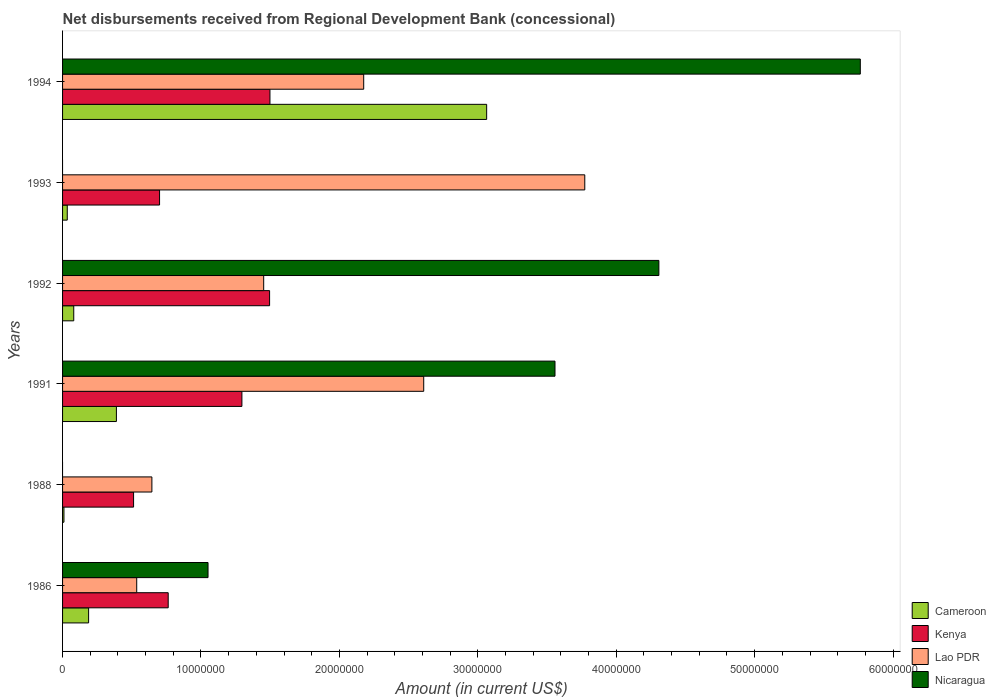How many different coloured bars are there?
Offer a terse response. 4. How many groups of bars are there?
Keep it short and to the point. 6. In how many cases, is the number of bars for a given year not equal to the number of legend labels?
Your response must be concise. 2. What is the amount of disbursements received from Regional Development Bank in Nicaragua in 1986?
Offer a very short reply. 1.05e+07. Across all years, what is the maximum amount of disbursements received from Regional Development Bank in Kenya?
Your response must be concise. 1.50e+07. What is the total amount of disbursements received from Regional Development Bank in Kenya in the graph?
Your answer should be compact. 6.27e+07. What is the difference between the amount of disbursements received from Regional Development Bank in Lao PDR in 1988 and that in 1991?
Your answer should be compact. -1.96e+07. What is the difference between the amount of disbursements received from Regional Development Bank in Cameroon in 1988 and the amount of disbursements received from Regional Development Bank in Kenya in 1986?
Ensure brevity in your answer.  -7.53e+06. What is the average amount of disbursements received from Regional Development Bank in Nicaragua per year?
Your answer should be compact. 2.45e+07. In the year 1986, what is the difference between the amount of disbursements received from Regional Development Bank in Cameroon and amount of disbursements received from Regional Development Bank in Nicaragua?
Your response must be concise. -8.63e+06. What is the ratio of the amount of disbursements received from Regional Development Bank in Nicaragua in 1986 to that in 1992?
Provide a short and direct response. 0.24. What is the difference between the highest and the second highest amount of disbursements received from Regional Development Bank in Nicaragua?
Give a very brief answer. 1.46e+07. What is the difference between the highest and the lowest amount of disbursements received from Regional Development Bank in Lao PDR?
Your answer should be very brief. 3.24e+07. In how many years, is the amount of disbursements received from Regional Development Bank in Lao PDR greater than the average amount of disbursements received from Regional Development Bank in Lao PDR taken over all years?
Your answer should be compact. 3. Is the sum of the amount of disbursements received from Regional Development Bank in Kenya in 1986 and 1988 greater than the maximum amount of disbursements received from Regional Development Bank in Nicaragua across all years?
Provide a short and direct response. No. Is it the case that in every year, the sum of the amount of disbursements received from Regional Development Bank in Kenya and amount of disbursements received from Regional Development Bank in Lao PDR is greater than the amount of disbursements received from Regional Development Bank in Cameroon?
Your response must be concise. Yes. Are all the bars in the graph horizontal?
Provide a succinct answer. Yes. What is the difference between two consecutive major ticks on the X-axis?
Offer a terse response. 1.00e+07. Where does the legend appear in the graph?
Make the answer very short. Bottom right. How are the legend labels stacked?
Make the answer very short. Vertical. What is the title of the graph?
Your answer should be very brief. Net disbursements received from Regional Development Bank (concessional). Does "Togo" appear as one of the legend labels in the graph?
Your answer should be compact. No. What is the Amount (in current US$) of Cameroon in 1986?
Make the answer very short. 1.88e+06. What is the Amount (in current US$) in Kenya in 1986?
Ensure brevity in your answer.  7.63e+06. What is the Amount (in current US$) in Lao PDR in 1986?
Ensure brevity in your answer.  5.36e+06. What is the Amount (in current US$) of Nicaragua in 1986?
Give a very brief answer. 1.05e+07. What is the Amount (in current US$) of Kenya in 1988?
Give a very brief answer. 5.13e+06. What is the Amount (in current US$) in Lao PDR in 1988?
Offer a very short reply. 6.45e+06. What is the Amount (in current US$) of Cameroon in 1991?
Provide a short and direct response. 3.89e+06. What is the Amount (in current US$) of Kenya in 1991?
Your answer should be very brief. 1.30e+07. What is the Amount (in current US$) of Lao PDR in 1991?
Offer a very short reply. 2.61e+07. What is the Amount (in current US$) of Nicaragua in 1991?
Your response must be concise. 3.56e+07. What is the Amount (in current US$) in Cameroon in 1992?
Your answer should be very brief. 8.08e+05. What is the Amount (in current US$) of Kenya in 1992?
Keep it short and to the point. 1.50e+07. What is the Amount (in current US$) of Lao PDR in 1992?
Ensure brevity in your answer.  1.45e+07. What is the Amount (in current US$) in Nicaragua in 1992?
Your response must be concise. 4.31e+07. What is the Amount (in current US$) of Kenya in 1993?
Make the answer very short. 7.01e+06. What is the Amount (in current US$) of Lao PDR in 1993?
Offer a very short reply. 3.77e+07. What is the Amount (in current US$) of Cameroon in 1994?
Offer a terse response. 3.06e+07. What is the Amount (in current US$) of Kenya in 1994?
Your answer should be very brief. 1.50e+07. What is the Amount (in current US$) of Lao PDR in 1994?
Provide a short and direct response. 2.18e+07. What is the Amount (in current US$) of Nicaragua in 1994?
Your response must be concise. 5.76e+07. Across all years, what is the maximum Amount (in current US$) in Cameroon?
Your answer should be compact. 3.06e+07. Across all years, what is the maximum Amount (in current US$) of Kenya?
Provide a short and direct response. 1.50e+07. Across all years, what is the maximum Amount (in current US$) in Lao PDR?
Keep it short and to the point. 3.77e+07. Across all years, what is the maximum Amount (in current US$) of Nicaragua?
Your answer should be very brief. 5.76e+07. Across all years, what is the minimum Amount (in current US$) in Cameroon?
Your answer should be compact. 1.00e+05. Across all years, what is the minimum Amount (in current US$) in Kenya?
Ensure brevity in your answer.  5.13e+06. Across all years, what is the minimum Amount (in current US$) of Lao PDR?
Make the answer very short. 5.36e+06. What is the total Amount (in current US$) in Cameroon in the graph?
Provide a succinct answer. 3.77e+07. What is the total Amount (in current US$) in Kenya in the graph?
Offer a terse response. 6.27e+07. What is the total Amount (in current US$) of Lao PDR in the graph?
Give a very brief answer. 1.12e+08. What is the total Amount (in current US$) of Nicaragua in the graph?
Make the answer very short. 1.47e+08. What is the difference between the Amount (in current US$) of Cameroon in 1986 and that in 1988?
Provide a succinct answer. 1.78e+06. What is the difference between the Amount (in current US$) in Kenya in 1986 and that in 1988?
Ensure brevity in your answer.  2.50e+06. What is the difference between the Amount (in current US$) of Lao PDR in 1986 and that in 1988?
Give a very brief answer. -1.10e+06. What is the difference between the Amount (in current US$) in Cameroon in 1986 and that in 1991?
Your response must be concise. -2.01e+06. What is the difference between the Amount (in current US$) in Kenya in 1986 and that in 1991?
Give a very brief answer. -5.32e+06. What is the difference between the Amount (in current US$) in Lao PDR in 1986 and that in 1991?
Provide a short and direct response. -2.07e+07. What is the difference between the Amount (in current US$) of Nicaragua in 1986 and that in 1991?
Provide a short and direct response. -2.51e+07. What is the difference between the Amount (in current US$) in Cameroon in 1986 and that in 1992?
Your response must be concise. 1.07e+06. What is the difference between the Amount (in current US$) of Kenya in 1986 and that in 1992?
Provide a short and direct response. -7.32e+06. What is the difference between the Amount (in current US$) of Lao PDR in 1986 and that in 1992?
Give a very brief answer. -9.17e+06. What is the difference between the Amount (in current US$) in Nicaragua in 1986 and that in 1992?
Provide a short and direct response. -3.26e+07. What is the difference between the Amount (in current US$) of Cameroon in 1986 and that in 1993?
Your answer should be very brief. 1.54e+06. What is the difference between the Amount (in current US$) of Kenya in 1986 and that in 1993?
Your answer should be compact. 6.24e+05. What is the difference between the Amount (in current US$) of Lao PDR in 1986 and that in 1993?
Your response must be concise. -3.24e+07. What is the difference between the Amount (in current US$) in Cameroon in 1986 and that in 1994?
Ensure brevity in your answer.  -2.88e+07. What is the difference between the Amount (in current US$) of Kenya in 1986 and that in 1994?
Offer a very short reply. -7.35e+06. What is the difference between the Amount (in current US$) of Lao PDR in 1986 and that in 1994?
Ensure brevity in your answer.  -1.64e+07. What is the difference between the Amount (in current US$) in Nicaragua in 1986 and that in 1994?
Give a very brief answer. -4.71e+07. What is the difference between the Amount (in current US$) in Cameroon in 1988 and that in 1991?
Keep it short and to the point. -3.79e+06. What is the difference between the Amount (in current US$) in Kenya in 1988 and that in 1991?
Your response must be concise. -7.83e+06. What is the difference between the Amount (in current US$) of Lao PDR in 1988 and that in 1991?
Your response must be concise. -1.96e+07. What is the difference between the Amount (in current US$) in Cameroon in 1988 and that in 1992?
Offer a terse response. -7.08e+05. What is the difference between the Amount (in current US$) of Kenya in 1988 and that in 1992?
Provide a short and direct response. -9.83e+06. What is the difference between the Amount (in current US$) of Lao PDR in 1988 and that in 1992?
Your response must be concise. -8.08e+06. What is the difference between the Amount (in current US$) in Cameroon in 1988 and that in 1993?
Offer a terse response. -2.40e+05. What is the difference between the Amount (in current US$) of Kenya in 1988 and that in 1993?
Keep it short and to the point. -1.88e+06. What is the difference between the Amount (in current US$) in Lao PDR in 1988 and that in 1993?
Provide a short and direct response. -3.13e+07. What is the difference between the Amount (in current US$) in Cameroon in 1988 and that in 1994?
Give a very brief answer. -3.05e+07. What is the difference between the Amount (in current US$) of Kenya in 1988 and that in 1994?
Offer a very short reply. -9.85e+06. What is the difference between the Amount (in current US$) in Lao PDR in 1988 and that in 1994?
Offer a very short reply. -1.53e+07. What is the difference between the Amount (in current US$) in Cameroon in 1991 and that in 1992?
Your answer should be very brief. 3.08e+06. What is the difference between the Amount (in current US$) of Lao PDR in 1991 and that in 1992?
Keep it short and to the point. 1.16e+07. What is the difference between the Amount (in current US$) of Nicaragua in 1991 and that in 1992?
Keep it short and to the point. -7.50e+06. What is the difference between the Amount (in current US$) of Cameroon in 1991 and that in 1993?
Offer a very short reply. 3.55e+06. What is the difference between the Amount (in current US$) of Kenya in 1991 and that in 1993?
Offer a very short reply. 5.95e+06. What is the difference between the Amount (in current US$) in Lao PDR in 1991 and that in 1993?
Give a very brief answer. -1.16e+07. What is the difference between the Amount (in current US$) in Cameroon in 1991 and that in 1994?
Offer a very short reply. -2.67e+07. What is the difference between the Amount (in current US$) in Kenya in 1991 and that in 1994?
Your response must be concise. -2.03e+06. What is the difference between the Amount (in current US$) of Lao PDR in 1991 and that in 1994?
Your answer should be compact. 4.34e+06. What is the difference between the Amount (in current US$) of Nicaragua in 1991 and that in 1994?
Make the answer very short. -2.21e+07. What is the difference between the Amount (in current US$) in Cameroon in 1992 and that in 1993?
Offer a very short reply. 4.68e+05. What is the difference between the Amount (in current US$) in Kenya in 1992 and that in 1993?
Your response must be concise. 7.95e+06. What is the difference between the Amount (in current US$) of Lao PDR in 1992 and that in 1993?
Provide a succinct answer. -2.32e+07. What is the difference between the Amount (in current US$) of Cameroon in 1992 and that in 1994?
Keep it short and to the point. -2.98e+07. What is the difference between the Amount (in current US$) of Kenya in 1992 and that in 1994?
Your answer should be compact. -2.60e+04. What is the difference between the Amount (in current US$) of Lao PDR in 1992 and that in 1994?
Make the answer very short. -7.23e+06. What is the difference between the Amount (in current US$) in Nicaragua in 1992 and that in 1994?
Your answer should be very brief. -1.46e+07. What is the difference between the Amount (in current US$) in Cameroon in 1993 and that in 1994?
Your answer should be compact. -3.03e+07. What is the difference between the Amount (in current US$) in Kenya in 1993 and that in 1994?
Offer a very short reply. -7.98e+06. What is the difference between the Amount (in current US$) of Lao PDR in 1993 and that in 1994?
Your answer should be compact. 1.60e+07. What is the difference between the Amount (in current US$) in Cameroon in 1986 and the Amount (in current US$) in Kenya in 1988?
Your answer should be compact. -3.25e+06. What is the difference between the Amount (in current US$) in Cameroon in 1986 and the Amount (in current US$) in Lao PDR in 1988?
Give a very brief answer. -4.57e+06. What is the difference between the Amount (in current US$) of Kenya in 1986 and the Amount (in current US$) of Lao PDR in 1988?
Make the answer very short. 1.18e+06. What is the difference between the Amount (in current US$) of Cameroon in 1986 and the Amount (in current US$) of Kenya in 1991?
Provide a short and direct response. -1.11e+07. What is the difference between the Amount (in current US$) in Cameroon in 1986 and the Amount (in current US$) in Lao PDR in 1991?
Make the answer very short. -2.42e+07. What is the difference between the Amount (in current US$) of Cameroon in 1986 and the Amount (in current US$) of Nicaragua in 1991?
Provide a short and direct response. -3.37e+07. What is the difference between the Amount (in current US$) of Kenya in 1986 and the Amount (in current US$) of Lao PDR in 1991?
Provide a succinct answer. -1.85e+07. What is the difference between the Amount (in current US$) in Kenya in 1986 and the Amount (in current US$) in Nicaragua in 1991?
Keep it short and to the point. -2.79e+07. What is the difference between the Amount (in current US$) in Lao PDR in 1986 and the Amount (in current US$) in Nicaragua in 1991?
Offer a very short reply. -3.02e+07. What is the difference between the Amount (in current US$) in Cameroon in 1986 and the Amount (in current US$) in Kenya in 1992?
Provide a short and direct response. -1.31e+07. What is the difference between the Amount (in current US$) of Cameroon in 1986 and the Amount (in current US$) of Lao PDR in 1992?
Keep it short and to the point. -1.26e+07. What is the difference between the Amount (in current US$) of Cameroon in 1986 and the Amount (in current US$) of Nicaragua in 1992?
Ensure brevity in your answer.  -4.12e+07. What is the difference between the Amount (in current US$) of Kenya in 1986 and the Amount (in current US$) of Lao PDR in 1992?
Your response must be concise. -6.90e+06. What is the difference between the Amount (in current US$) of Kenya in 1986 and the Amount (in current US$) of Nicaragua in 1992?
Give a very brief answer. -3.54e+07. What is the difference between the Amount (in current US$) in Lao PDR in 1986 and the Amount (in current US$) in Nicaragua in 1992?
Make the answer very short. -3.77e+07. What is the difference between the Amount (in current US$) in Cameroon in 1986 and the Amount (in current US$) in Kenya in 1993?
Your answer should be compact. -5.13e+06. What is the difference between the Amount (in current US$) in Cameroon in 1986 and the Amount (in current US$) in Lao PDR in 1993?
Your answer should be very brief. -3.58e+07. What is the difference between the Amount (in current US$) of Kenya in 1986 and the Amount (in current US$) of Lao PDR in 1993?
Offer a very short reply. -3.01e+07. What is the difference between the Amount (in current US$) of Cameroon in 1986 and the Amount (in current US$) of Kenya in 1994?
Ensure brevity in your answer.  -1.31e+07. What is the difference between the Amount (in current US$) of Cameroon in 1986 and the Amount (in current US$) of Lao PDR in 1994?
Your response must be concise. -1.99e+07. What is the difference between the Amount (in current US$) of Cameroon in 1986 and the Amount (in current US$) of Nicaragua in 1994?
Keep it short and to the point. -5.58e+07. What is the difference between the Amount (in current US$) of Kenya in 1986 and the Amount (in current US$) of Lao PDR in 1994?
Offer a terse response. -1.41e+07. What is the difference between the Amount (in current US$) of Kenya in 1986 and the Amount (in current US$) of Nicaragua in 1994?
Your answer should be very brief. -5.00e+07. What is the difference between the Amount (in current US$) of Lao PDR in 1986 and the Amount (in current US$) of Nicaragua in 1994?
Give a very brief answer. -5.23e+07. What is the difference between the Amount (in current US$) of Cameroon in 1988 and the Amount (in current US$) of Kenya in 1991?
Your response must be concise. -1.29e+07. What is the difference between the Amount (in current US$) in Cameroon in 1988 and the Amount (in current US$) in Lao PDR in 1991?
Give a very brief answer. -2.60e+07. What is the difference between the Amount (in current US$) in Cameroon in 1988 and the Amount (in current US$) in Nicaragua in 1991?
Offer a very short reply. -3.55e+07. What is the difference between the Amount (in current US$) of Kenya in 1988 and the Amount (in current US$) of Lao PDR in 1991?
Make the answer very short. -2.10e+07. What is the difference between the Amount (in current US$) in Kenya in 1988 and the Amount (in current US$) in Nicaragua in 1991?
Your answer should be compact. -3.04e+07. What is the difference between the Amount (in current US$) of Lao PDR in 1988 and the Amount (in current US$) of Nicaragua in 1991?
Offer a terse response. -2.91e+07. What is the difference between the Amount (in current US$) of Cameroon in 1988 and the Amount (in current US$) of Kenya in 1992?
Provide a succinct answer. -1.49e+07. What is the difference between the Amount (in current US$) of Cameroon in 1988 and the Amount (in current US$) of Lao PDR in 1992?
Your answer should be very brief. -1.44e+07. What is the difference between the Amount (in current US$) of Cameroon in 1988 and the Amount (in current US$) of Nicaragua in 1992?
Your answer should be very brief. -4.30e+07. What is the difference between the Amount (in current US$) in Kenya in 1988 and the Amount (in current US$) in Lao PDR in 1992?
Your answer should be very brief. -9.40e+06. What is the difference between the Amount (in current US$) of Kenya in 1988 and the Amount (in current US$) of Nicaragua in 1992?
Ensure brevity in your answer.  -3.80e+07. What is the difference between the Amount (in current US$) of Lao PDR in 1988 and the Amount (in current US$) of Nicaragua in 1992?
Ensure brevity in your answer.  -3.66e+07. What is the difference between the Amount (in current US$) in Cameroon in 1988 and the Amount (in current US$) in Kenya in 1993?
Offer a terse response. -6.91e+06. What is the difference between the Amount (in current US$) in Cameroon in 1988 and the Amount (in current US$) in Lao PDR in 1993?
Provide a succinct answer. -3.76e+07. What is the difference between the Amount (in current US$) in Kenya in 1988 and the Amount (in current US$) in Lao PDR in 1993?
Make the answer very short. -3.26e+07. What is the difference between the Amount (in current US$) of Cameroon in 1988 and the Amount (in current US$) of Kenya in 1994?
Give a very brief answer. -1.49e+07. What is the difference between the Amount (in current US$) of Cameroon in 1988 and the Amount (in current US$) of Lao PDR in 1994?
Your answer should be compact. -2.17e+07. What is the difference between the Amount (in current US$) of Cameroon in 1988 and the Amount (in current US$) of Nicaragua in 1994?
Your answer should be very brief. -5.75e+07. What is the difference between the Amount (in current US$) of Kenya in 1988 and the Amount (in current US$) of Lao PDR in 1994?
Keep it short and to the point. -1.66e+07. What is the difference between the Amount (in current US$) in Kenya in 1988 and the Amount (in current US$) in Nicaragua in 1994?
Provide a short and direct response. -5.25e+07. What is the difference between the Amount (in current US$) of Lao PDR in 1988 and the Amount (in current US$) of Nicaragua in 1994?
Offer a very short reply. -5.12e+07. What is the difference between the Amount (in current US$) of Cameroon in 1991 and the Amount (in current US$) of Kenya in 1992?
Your response must be concise. -1.11e+07. What is the difference between the Amount (in current US$) of Cameroon in 1991 and the Amount (in current US$) of Lao PDR in 1992?
Your response must be concise. -1.06e+07. What is the difference between the Amount (in current US$) in Cameroon in 1991 and the Amount (in current US$) in Nicaragua in 1992?
Ensure brevity in your answer.  -3.92e+07. What is the difference between the Amount (in current US$) of Kenya in 1991 and the Amount (in current US$) of Lao PDR in 1992?
Your answer should be compact. -1.57e+06. What is the difference between the Amount (in current US$) in Kenya in 1991 and the Amount (in current US$) in Nicaragua in 1992?
Offer a very short reply. -3.01e+07. What is the difference between the Amount (in current US$) in Lao PDR in 1991 and the Amount (in current US$) in Nicaragua in 1992?
Make the answer very short. -1.70e+07. What is the difference between the Amount (in current US$) in Cameroon in 1991 and the Amount (in current US$) in Kenya in 1993?
Ensure brevity in your answer.  -3.12e+06. What is the difference between the Amount (in current US$) in Cameroon in 1991 and the Amount (in current US$) in Lao PDR in 1993?
Make the answer very short. -3.38e+07. What is the difference between the Amount (in current US$) of Kenya in 1991 and the Amount (in current US$) of Lao PDR in 1993?
Your response must be concise. -2.48e+07. What is the difference between the Amount (in current US$) in Cameroon in 1991 and the Amount (in current US$) in Kenya in 1994?
Your response must be concise. -1.11e+07. What is the difference between the Amount (in current US$) of Cameroon in 1991 and the Amount (in current US$) of Lao PDR in 1994?
Make the answer very short. -1.79e+07. What is the difference between the Amount (in current US$) in Cameroon in 1991 and the Amount (in current US$) in Nicaragua in 1994?
Make the answer very short. -5.37e+07. What is the difference between the Amount (in current US$) of Kenya in 1991 and the Amount (in current US$) of Lao PDR in 1994?
Keep it short and to the point. -8.80e+06. What is the difference between the Amount (in current US$) in Kenya in 1991 and the Amount (in current US$) in Nicaragua in 1994?
Make the answer very short. -4.47e+07. What is the difference between the Amount (in current US$) in Lao PDR in 1991 and the Amount (in current US$) in Nicaragua in 1994?
Offer a terse response. -3.15e+07. What is the difference between the Amount (in current US$) of Cameroon in 1992 and the Amount (in current US$) of Kenya in 1993?
Keep it short and to the point. -6.20e+06. What is the difference between the Amount (in current US$) in Cameroon in 1992 and the Amount (in current US$) in Lao PDR in 1993?
Your response must be concise. -3.69e+07. What is the difference between the Amount (in current US$) of Kenya in 1992 and the Amount (in current US$) of Lao PDR in 1993?
Provide a succinct answer. -2.28e+07. What is the difference between the Amount (in current US$) of Cameroon in 1992 and the Amount (in current US$) of Kenya in 1994?
Make the answer very short. -1.42e+07. What is the difference between the Amount (in current US$) in Cameroon in 1992 and the Amount (in current US$) in Lao PDR in 1994?
Offer a terse response. -2.09e+07. What is the difference between the Amount (in current US$) of Cameroon in 1992 and the Amount (in current US$) of Nicaragua in 1994?
Give a very brief answer. -5.68e+07. What is the difference between the Amount (in current US$) of Kenya in 1992 and the Amount (in current US$) of Lao PDR in 1994?
Give a very brief answer. -6.80e+06. What is the difference between the Amount (in current US$) of Kenya in 1992 and the Amount (in current US$) of Nicaragua in 1994?
Keep it short and to the point. -4.27e+07. What is the difference between the Amount (in current US$) in Lao PDR in 1992 and the Amount (in current US$) in Nicaragua in 1994?
Offer a terse response. -4.31e+07. What is the difference between the Amount (in current US$) of Cameroon in 1993 and the Amount (in current US$) of Kenya in 1994?
Offer a very short reply. -1.46e+07. What is the difference between the Amount (in current US$) of Cameroon in 1993 and the Amount (in current US$) of Lao PDR in 1994?
Give a very brief answer. -2.14e+07. What is the difference between the Amount (in current US$) of Cameroon in 1993 and the Amount (in current US$) of Nicaragua in 1994?
Provide a succinct answer. -5.73e+07. What is the difference between the Amount (in current US$) in Kenya in 1993 and the Amount (in current US$) in Lao PDR in 1994?
Offer a very short reply. -1.47e+07. What is the difference between the Amount (in current US$) in Kenya in 1993 and the Amount (in current US$) in Nicaragua in 1994?
Your answer should be very brief. -5.06e+07. What is the difference between the Amount (in current US$) of Lao PDR in 1993 and the Amount (in current US$) of Nicaragua in 1994?
Offer a very short reply. -1.99e+07. What is the average Amount (in current US$) of Cameroon per year?
Offer a terse response. 6.28e+06. What is the average Amount (in current US$) in Kenya per year?
Offer a terse response. 1.04e+07. What is the average Amount (in current US$) in Lao PDR per year?
Offer a terse response. 1.87e+07. What is the average Amount (in current US$) of Nicaragua per year?
Offer a terse response. 2.45e+07. In the year 1986, what is the difference between the Amount (in current US$) of Cameroon and Amount (in current US$) of Kenya?
Offer a very short reply. -5.75e+06. In the year 1986, what is the difference between the Amount (in current US$) in Cameroon and Amount (in current US$) in Lao PDR?
Your answer should be compact. -3.48e+06. In the year 1986, what is the difference between the Amount (in current US$) in Cameroon and Amount (in current US$) in Nicaragua?
Your answer should be compact. -8.63e+06. In the year 1986, what is the difference between the Amount (in current US$) in Kenya and Amount (in current US$) in Lao PDR?
Provide a succinct answer. 2.28e+06. In the year 1986, what is the difference between the Amount (in current US$) of Kenya and Amount (in current US$) of Nicaragua?
Keep it short and to the point. -2.88e+06. In the year 1986, what is the difference between the Amount (in current US$) of Lao PDR and Amount (in current US$) of Nicaragua?
Your response must be concise. -5.15e+06. In the year 1988, what is the difference between the Amount (in current US$) in Cameroon and Amount (in current US$) in Kenya?
Your answer should be very brief. -5.03e+06. In the year 1988, what is the difference between the Amount (in current US$) of Cameroon and Amount (in current US$) of Lao PDR?
Offer a very short reply. -6.35e+06. In the year 1988, what is the difference between the Amount (in current US$) of Kenya and Amount (in current US$) of Lao PDR?
Give a very brief answer. -1.32e+06. In the year 1991, what is the difference between the Amount (in current US$) of Cameroon and Amount (in current US$) of Kenya?
Provide a short and direct response. -9.07e+06. In the year 1991, what is the difference between the Amount (in current US$) of Cameroon and Amount (in current US$) of Lao PDR?
Make the answer very short. -2.22e+07. In the year 1991, what is the difference between the Amount (in current US$) in Cameroon and Amount (in current US$) in Nicaragua?
Provide a short and direct response. -3.17e+07. In the year 1991, what is the difference between the Amount (in current US$) of Kenya and Amount (in current US$) of Lao PDR?
Provide a succinct answer. -1.31e+07. In the year 1991, what is the difference between the Amount (in current US$) in Kenya and Amount (in current US$) in Nicaragua?
Ensure brevity in your answer.  -2.26e+07. In the year 1991, what is the difference between the Amount (in current US$) in Lao PDR and Amount (in current US$) in Nicaragua?
Ensure brevity in your answer.  -9.48e+06. In the year 1992, what is the difference between the Amount (in current US$) of Cameroon and Amount (in current US$) of Kenya?
Provide a succinct answer. -1.41e+07. In the year 1992, what is the difference between the Amount (in current US$) of Cameroon and Amount (in current US$) of Lao PDR?
Ensure brevity in your answer.  -1.37e+07. In the year 1992, what is the difference between the Amount (in current US$) in Cameroon and Amount (in current US$) in Nicaragua?
Your response must be concise. -4.23e+07. In the year 1992, what is the difference between the Amount (in current US$) in Kenya and Amount (in current US$) in Lao PDR?
Keep it short and to the point. 4.27e+05. In the year 1992, what is the difference between the Amount (in current US$) of Kenya and Amount (in current US$) of Nicaragua?
Make the answer very short. -2.81e+07. In the year 1992, what is the difference between the Amount (in current US$) in Lao PDR and Amount (in current US$) in Nicaragua?
Keep it short and to the point. -2.86e+07. In the year 1993, what is the difference between the Amount (in current US$) in Cameroon and Amount (in current US$) in Kenya?
Make the answer very short. -6.67e+06. In the year 1993, what is the difference between the Amount (in current US$) of Cameroon and Amount (in current US$) of Lao PDR?
Provide a succinct answer. -3.74e+07. In the year 1993, what is the difference between the Amount (in current US$) of Kenya and Amount (in current US$) of Lao PDR?
Make the answer very short. -3.07e+07. In the year 1994, what is the difference between the Amount (in current US$) in Cameroon and Amount (in current US$) in Kenya?
Keep it short and to the point. 1.57e+07. In the year 1994, what is the difference between the Amount (in current US$) in Cameroon and Amount (in current US$) in Lao PDR?
Make the answer very short. 8.88e+06. In the year 1994, what is the difference between the Amount (in current US$) in Cameroon and Amount (in current US$) in Nicaragua?
Keep it short and to the point. -2.70e+07. In the year 1994, what is the difference between the Amount (in current US$) of Kenya and Amount (in current US$) of Lao PDR?
Ensure brevity in your answer.  -6.77e+06. In the year 1994, what is the difference between the Amount (in current US$) in Kenya and Amount (in current US$) in Nicaragua?
Provide a succinct answer. -4.27e+07. In the year 1994, what is the difference between the Amount (in current US$) of Lao PDR and Amount (in current US$) of Nicaragua?
Keep it short and to the point. -3.59e+07. What is the ratio of the Amount (in current US$) of Cameroon in 1986 to that in 1988?
Provide a short and direct response. 18.82. What is the ratio of the Amount (in current US$) in Kenya in 1986 to that in 1988?
Provide a short and direct response. 1.49. What is the ratio of the Amount (in current US$) of Lao PDR in 1986 to that in 1988?
Keep it short and to the point. 0.83. What is the ratio of the Amount (in current US$) of Cameroon in 1986 to that in 1991?
Make the answer very short. 0.48. What is the ratio of the Amount (in current US$) of Kenya in 1986 to that in 1991?
Your answer should be compact. 0.59. What is the ratio of the Amount (in current US$) in Lao PDR in 1986 to that in 1991?
Your response must be concise. 0.21. What is the ratio of the Amount (in current US$) in Nicaragua in 1986 to that in 1991?
Your answer should be very brief. 0.3. What is the ratio of the Amount (in current US$) of Cameroon in 1986 to that in 1992?
Provide a short and direct response. 2.33. What is the ratio of the Amount (in current US$) of Kenya in 1986 to that in 1992?
Keep it short and to the point. 0.51. What is the ratio of the Amount (in current US$) of Lao PDR in 1986 to that in 1992?
Your response must be concise. 0.37. What is the ratio of the Amount (in current US$) in Nicaragua in 1986 to that in 1992?
Ensure brevity in your answer.  0.24. What is the ratio of the Amount (in current US$) in Cameroon in 1986 to that in 1993?
Provide a succinct answer. 5.54. What is the ratio of the Amount (in current US$) of Kenya in 1986 to that in 1993?
Your response must be concise. 1.09. What is the ratio of the Amount (in current US$) in Lao PDR in 1986 to that in 1993?
Provide a short and direct response. 0.14. What is the ratio of the Amount (in current US$) of Cameroon in 1986 to that in 1994?
Provide a short and direct response. 0.06. What is the ratio of the Amount (in current US$) of Kenya in 1986 to that in 1994?
Your answer should be compact. 0.51. What is the ratio of the Amount (in current US$) of Lao PDR in 1986 to that in 1994?
Ensure brevity in your answer.  0.25. What is the ratio of the Amount (in current US$) in Nicaragua in 1986 to that in 1994?
Your answer should be compact. 0.18. What is the ratio of the Amount (in current US$) in Cameroon in 1988 to that in 1991?
Your answer should be compact. 0.03. What is the ratio of the Amount (in current US$) in Kenya in 1988 to that in 1991?
Offer a terse response. 0.4. What is the ratio of the Amount (in current US$) of Lao PDR in 1988 to that in 1991?
Give a very brief answer. 0.25. What is the ratio of the Amount (in current US$) of Cameroon in 1988 to that in 1992?
Your answer should be compact. 0.12. What is the ratio of the Amount (in current US$) of Kenya in 1988 to that in 1992?
Your answer should be very brief. 0.34. What is the ratio of the Amount (in current US$) in Lao PDR in 1988 to that in 1992?
Give a very brief answer. 0.44. What is the ratio of the Amount (in current US$) in Cameroon in 1988 to that in 1993?
Keep it short and to the point. 0.29. What is the ratio of the Amount (in current US$) of Kenya in 1988 to that in 1993?
Provide a short and direct response. 0.73. What is the ratio of the Amount (in current US$) in Lao PDR in 1988 to that in 1993?
Your response must be concise. 0.17. What is the ratio of the Amount (in current US$) of Cameroon in 1988 to that in 1994?
Ensure brevity in your answer.  0. What is the ratio of the Amount (in current US$) in Kenya in 1988 to that in 1994?
Your answer should be very brief. 0.34. What is the ratio of the Amount (in current US$) in Lao PDR in 1988 to that in 1994?
Give a very brief answer. 0.3. What is the ratio of the Amount (in current US$) in Cameroon in 1991 to that in 1992?
Offer a very short reply. 4.81. What is the ratio of the Amount (in current US$) in Kenya in 1991 to that in 1992?
Make the answer very short. 0.87. What is the ratio of the Amount (in current US$) in Lao PDR in 1991 to that in 1992?
Make the answer very short. 1.8. What is the ratio of the Amount (in current US$) in Nicaragua in 1991 to that in 1992?
Offer a very short reply. 0.83. What is the ratio of the Amount (in current US$) in Cameroon in 1991 to that in 1993?
Provide a succinct answer. 11.44. What is the ratio of the Amount (in current US$) in Kenya in 1991 to that in 1993?
Offer a very short reply. 1.85. What is the ratio of the Amount (in current US$) of Lao PDR in 1991 to that in 1993?
Keep it short and to the point. 0.69. What is the ratio of the Amount (in current US$) of Cameroon in 1991 to that in 1994?
Give a very brief answer. 0.13. What is the ratio of the Amount (in current US$) in Kenya in 1991 to that in 1994?
Your answer should be compact. 0.86. What is the ratio of the Amount (in current US$) in Lao PDR in 1991 to that in 1994?
Give a very brief answer. 1.2. What is the ratio of the Amount (in current US$) of Nicaragua in 1991 to that in 1994?
Provide a succinct answer. 0.62. What is the ratio of the Amount (in current US$) in Cameroon in 1992 to that in 1993?
Your answer should be compact. 2.38. What is the ratio of the Amount (in current US$) of Kenya in 1992 to that in 1993?
Give a very brief answer. 2.13. What is the ratio of the Amount (in current US$) in Lao PDR in 1992 to that in 1993?
Offer a very short reply. 0.39. What is the ratio of the Amount (in current US$) in Cameroon in 1992 to that in 1994?
Ensure brevity in your answer.  0.03. What is the ratio of the Amount (in current US$) in Lao PDR in 1992 to that in 1994?
Your answer should be compact. 0.67. What is the ratio of the Amount (in current US$) of Nicaragua in 1992 to that in 1994?
Keep it short and to the point. 0.75. What is the ratio of the Amount (in current US$) in Cameroon in 1993 to that in 1994?
Make the answer very short. 0.01. What is the ratio of the Amount (in current US$) in Kenya in 1993 to that in 1994?
Ensure brevity in your answer.  0.47. What is the ratio of the Amount (in current US$) in Lao PDR in 1993 to that in 1994?
Offer a terse response. 1.73. What is the difference between the highest and the second highest Amount (in current US$) in Cameroon?
Make the answer very short. 2.67e+07. What is the difference between the highest and the second highest Amount (in current US$) of Kenya?
Provide a short and direct response. 2.60e+04. What is the difference between the highest and the second highest Amount (in current US$) of Lao PDR?
Keep it short and to the point. 1.16e+07. What is the difference between the highest and the second highest Amount (in current US$) of Nicaragua?
Ensure brevity in your answer.  1.46e+07. What is the difference between the highest and the lowest Amount (in current US$) of Cameroon?
Provide a succinct answer. 3.05e+07. What is the difference between the highest and the lowest Amount (in current US$) in Kenya?
Make the answer very short. 9.85e+06. What is the difference between the highest and the lowest Amount (in current US$) in Lao PDR?
Ensure brevity in your answer.  3.24e+07. What is the difference between the highest and the lowest Amount (in current US$) in Nicaragua?
Offer a terse response. 5.76e+07. 